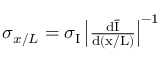Convert formula to latex. <formula><loc_0><loc_0><loc_500><loc_500>\begin{array} { r } { \sigma _ { x / L } = \sigma _ { I } \left | \frac { d \overline { I } } { d ( x / L ) } \right | ^ { - 1 } } \end{array}</formula> 